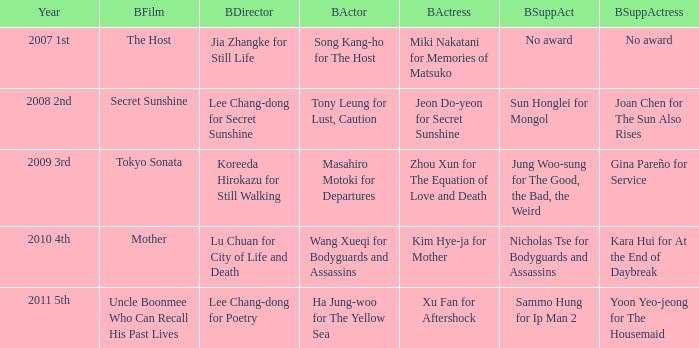Name the best director for mother Lu Chuan for City of Life and Death. 